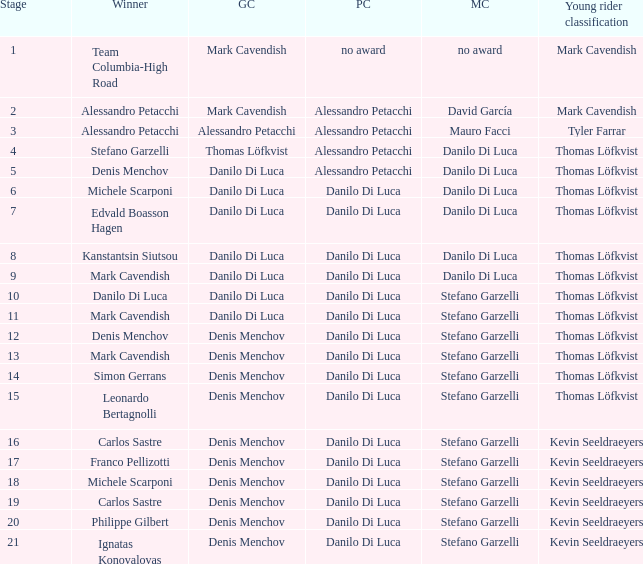When  thomas löfkvist is the general classification who is the winner? Stefano Garzelli. 